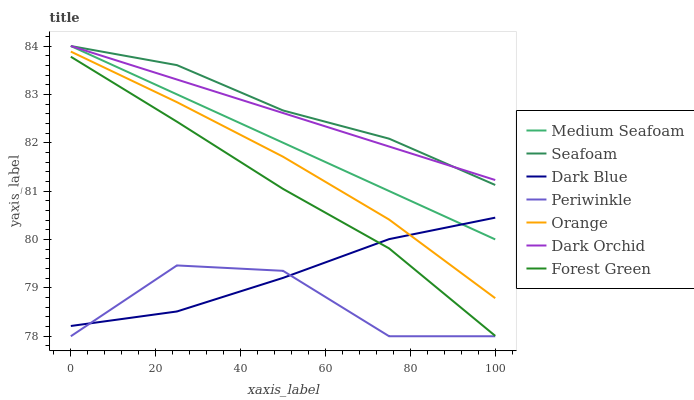Does Periwinkle have the minimum area under the curve?
Answer yes or no. Yes. Does Seafoam have the maximum area under the curve?
Answer yes or no. Yes. Does Dark Orchid have the minimum area under the curve?
Answer yes or no. No. Does Dark Orchid have the maximum area under the curve?
Answer yes or no. No. Is Dark Orchid the smoothest?
Answer yes or no. Yes. Is Periwinkle the roughest?
Answer yes or no. Yes. Is Dark Blue the smoothest?
Answer yes or no. No. Is Dark Blue the roughest?
Answer yes or no. No. Does Dark Blue have the lowest value?
Answer yes or no. No. Does Dark Blue have the highest value?
Answer yes or no. No. Is Forest Green less than Seafoam?
Answer yes or no. Yes. Is Dark Orchid greater than Dark Blue?
Answer yes or no. Yes. Does Forest Green intersect Seafoam?
Answer yes or no. No. 